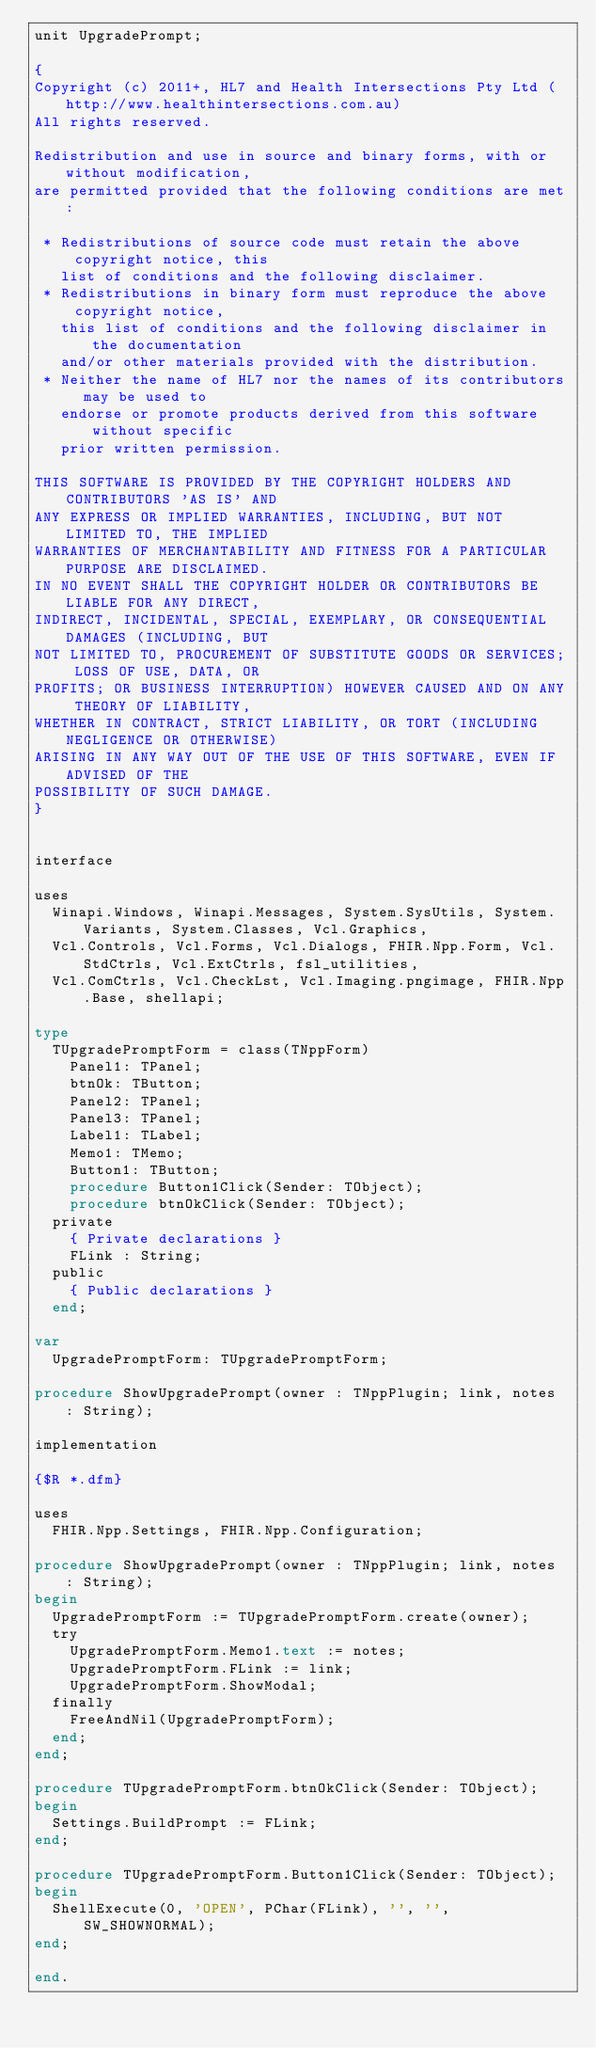Convert code to text. <code><loc_0><loc_0><loc_500><loc_500><_Pascal_>unit UpgradePrompt;

{
Copyright (c) 2011+, HL7 and Health Intersections Pty Ltd (http://www.healthintersections.com.au)
All rights reserved.

Redistribution and use in source and binary forms, with or without modification,
are permitted provided that the following conditions are met:

 * Redistributions of source code must retain the above copyright notice, this
   list of conditions and the following disclaimer.
 * Redistributions in binary form must reproduce the above copyright notice,
   this list of conditions and the following disclaimer in the documentation
   and/or other materials provided with the distribution.
 * Neither the name of HL7 nor the names of its contributors may be used to
   endorse or promote products derived from this software without specific
   prior written permission.

THIS SOFTWARE IS PROVIDED BY THE COPYRIGHT HOLDERS AND CONTRIBUTORS 'AS IS' AND
ANY EXPRESS OR IMPLIED WARRANTIES, INCLUDING, BUT NOT LIMITED TO, THE IMPLIED
WARRANTIES OF MERCHANTABILITY AND FITNESS FOR A PARTICULAR PURPOSE ARE DISCLAIMED.
IN NO EVENT SHALL THE COPYRIGHT HOLDER OR CONTRIBUTORS BE LIABLE FOR ANY DIRECT,
INDIRECT, INCIDENTAL, SPECIAL, EXEMPLARY, OR CONSEQUENTIAL DAMAGES (INCLUDING, BUT
NOT LIMITED TO, PROCUREMENT OF SUBSTITUTE GOODS OR SERVICES; LOSS OF USE, DATA, OR
PROFITS; OR BUSINESS INTERRUPTION) HOWEVER CAUSED AND ON ANY THEORY OF LIABILITY,
WHETHER IN CONTRACT, STRICT LIABILITY, OR TORT (INCLUDING NEGLIGENCE OR OTHERWISE)
ARISING IN ANY WAY OUT OF THE USE OF THIS SOFTWARE, EVEN IF ADVISED OF THE
POSSIBILITY OF SUCH DAMAGE.
}


interface

uses
  Winapi.Windows, Winapi.Messages, System.SysUtils, System.Variants, System.Classes, Vcl.Graphics,
  Vcl.Controls, Vcl.Forms, Vcl.Dialogs, FHIR.Npp.Form, Vcl.StdCtrls, Vcl.ExtCtrls, fsl_utilities,
  Vcl.ComCtrls, Vcl.CheckLst, Vcl.Imaging.pngimage, FHIR.Npp.Base, shellapi;

type
  TUpgradePromptForm = class(TNppForm)
    Panel1: TPanel;
    btnOk: TButton;
    Panel2: TPanel;
    Panel3: TPanel;
    Label1: TLabel;
    Memo1: TMemo;
    Button1: TButton;
    procedure Button1Click(Sender: TObject);
    procedure btnOkClick(Sender: TObject);
  private
    { Private declarations }
    FLink : String;
  public
    { Public declarations }
  end;

var
  UpgradePromptForm: TUpgradePromptForm;

procedure ShowUpgradePrompt(owner : TNppPlugin; link, notes : String);

implementation

{$R *.dfm}

uses
  FHIR.Npp.Settings, FHIR.Npp.Configuration;

procedure ShowUpgradePrompt(owner : TNppPlugin; link, notes : String);
begin
  UpgradePromptForm := TUpgradePromptForm.create(owner);
  try
    UpgradePromptForm.Memo1.text := notes;
    UpgradePromptForm.FLink := link;
    UpgradePromptForm.ShowModal;
  finally
    FreeAndNil(UpgradePromptForm);
  end;
end;

procedure TUpgradePromptForm.btnOkClick(Sender: TObject);
begin
  Settings.BuildPrompt := FLink;
end;

procedure TUpgradePromptForm.Button1Click(Sender: TObject);
begin
  ShellExecute(0, 'OPEN', PChar(FLink), '', '', SW_SHOWNORMAL);
end;

end.
</code> 